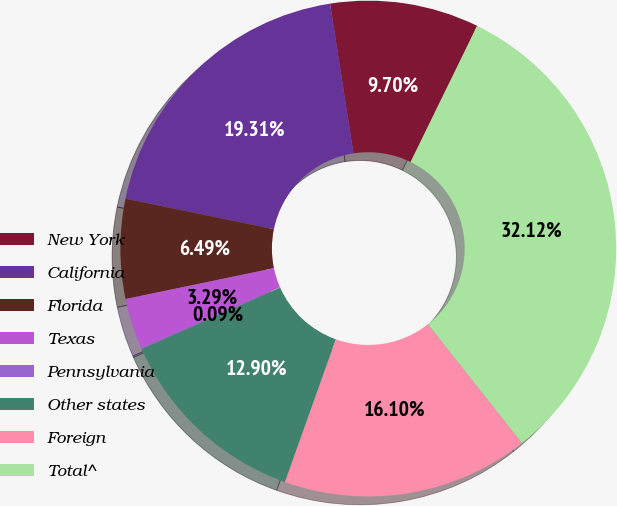Convert chart. <chart><loc_0><loc_0><loc_500><loc_500><pie_chart><fcel>New York<fcel>California<fcel>Florida<fcel>Texas<fcel>Pennsylvania<fcel>Other states<fcel>Foreign<fcel>Total^<nl><fcel>9.7%<fcel>19.31%<fcel>6.49%<fcel>3.29%<fcel>0.09%<fcel>12.9%<fcel>16.1%<fcel>32.12%<nl></chart> 